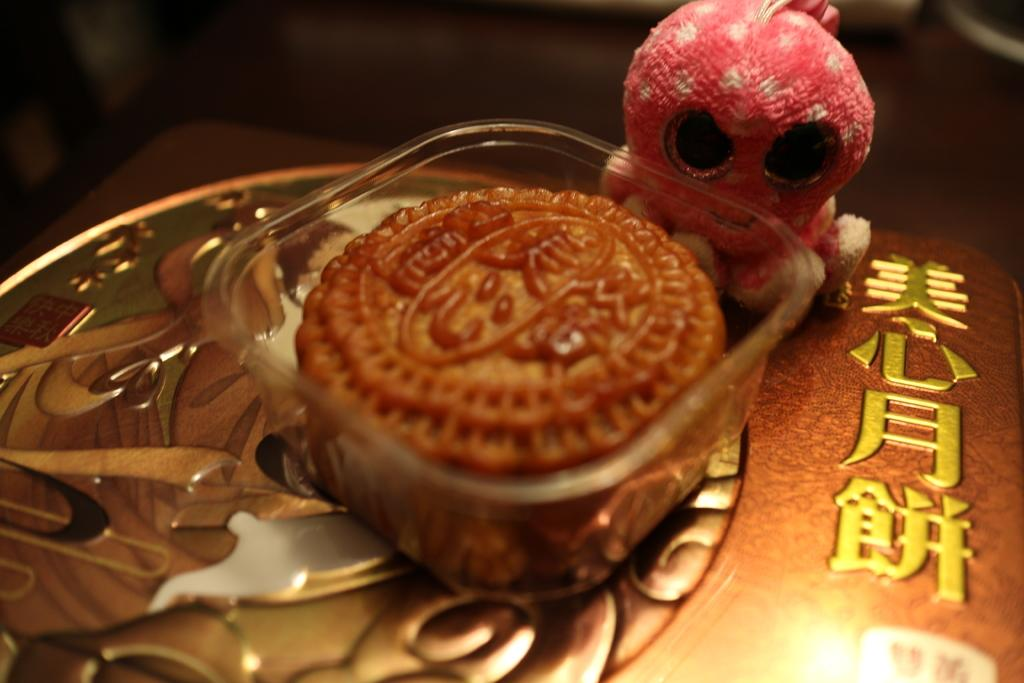What is on the table in the image? There is a bowl on a table in the image. What is inside the bowl? The bowl contains food. Can you describe anything else in the image besides the bowl and table? Yes, there is a toy in the top right of the image. What type of honey is being served by the mom at the event in the image? There is no mom or event present in the image, and no honey is mentioned. 